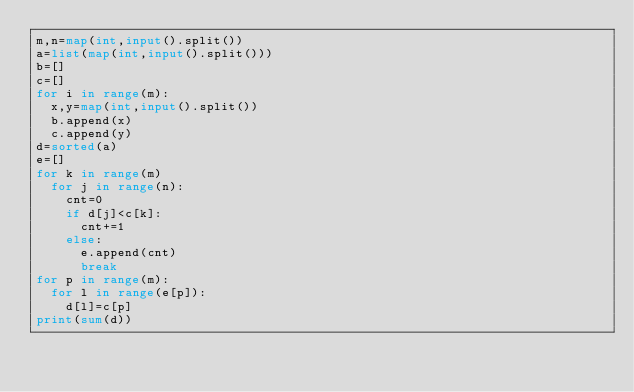<code> <loc_0><loc_0><loc_500><loc_500><_Python_>m,n=map(int,input().split())
a=list(map(int,input().split()))
b=[]
c=[]
for i in range(m):
  x,y=map(int,input().split())
  b.append(x)
  c.append(y)
d=sorted(a)
e=[]
for k in range(m)
  for j in range(n):
    cnt=0
    if d[j]<c[k]:
      cnt+=1
    else:
      e.append(cnt)
      break
for p in range(m):
  for l in range(e[p]):
    d[l]=c[p]
print(sum(d))
 
  
   
    
  
</code> 